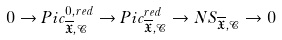Convert formula to latex. <formula><loc_0><loc_0><loc_500><loc_500>0 \rightarrow P i c _ { \overline { \mathfrak { X } } , \mathcal { C } } ^ { 0 , r e d } \rightarrow P i c _ { \overline { \mathfrak { X } } , \mathcal { C } } ^ { r e d } \rightarrow N S _ { \overline { \mathfrak { X } } , \mathcal { C } } \rightarrow 0</formula> 